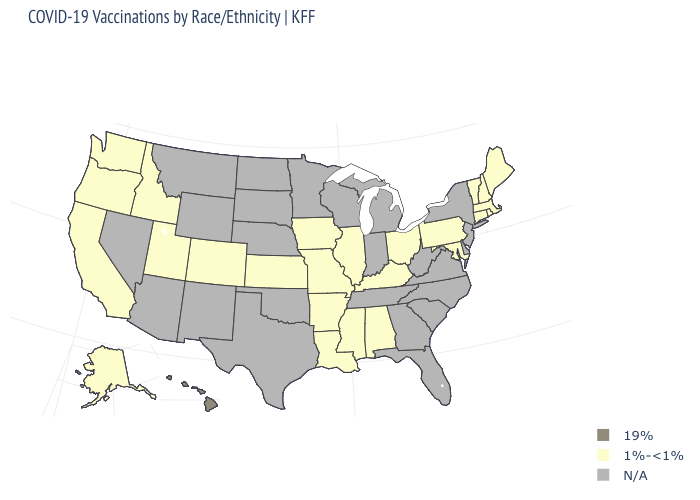What is the value of New Mexico?
Short answer required. N/A. Is the legend a continuous bar?
Keep it brief. No. Does the map have missing data?
Be succinct. Yes. What is the value of Virginia?
Write a very short answer. N/A. What is the value of New Mexico?
Short answer required. N/A. What is the value of New Jersey?
Be succinct. N/A. Does Mississippi have the highest value in the USA?
Keep it brief. No. Does the first symbol in the legend represent the smallest category?
Keep it brief. No. Name the states that have a value in the range 1%-<1%?
Concise answer only. Alabama, Alaska, Arkansas, California, Colorado, Connecticut, Idaho, Illinois, Iowa, Kansas, Kentucky, Louisiana, Maine, Maryland, Massachusetts, Mississippi, Missouri, New Hampshire, Ohio, Oregon, Pennsylvania, Rhode Island, Utah, Vermont, Washington. What is the highest value in the USA?
Write a very short answer. 19%. Name the states that have a value in the range N/A?
Quick response, please. Arizona, Delaware, Florida, Georgia, Indiana, Michigan, Minnesota, Montana, Nebraska, Nevada, New Jersey, New Mexico, New York, North Carolina, North Dakota, Oklahoma, South Carolina, South Dakota, Tennessee, Texas, Virginia, West Virginia, Wisconsin, Wyoming. Which states hav the highest value in the Northeast?
Short answer required. Connecticut, Maine, Massachusetts, New Hampshire, Pennsylvania, Rhode Island, Vermont. Does the first symbol in the legend represent the smallest category?
Answer briefly. No. 